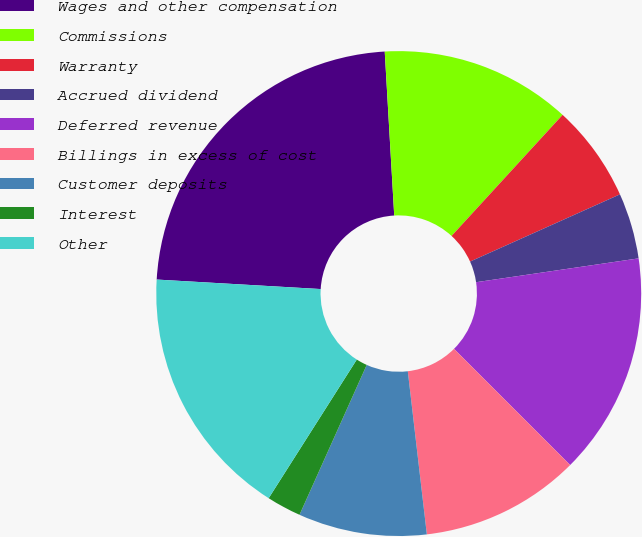Convert chart to OTSL. <chart><loc_0><loc_0><loc_500><loc_500><pie_chart><fcel>Wages and other compensation<fcel>Commissions<fcel>Warranty<fcel>Accrued dividend<fcel>Deferred revenue<fcel>Billings in excess of cost<fcel>Customer deposits<fcel>Interest<fcel>Other<nl><fcel>23.16%<fcel>12.73%<fcel>6.48%<fcel>4.39%<fcel>14.82%<fcel>10.65%<fcel>8.56%<fcel>2.3%<fcel>16.91%<nl></chart> 